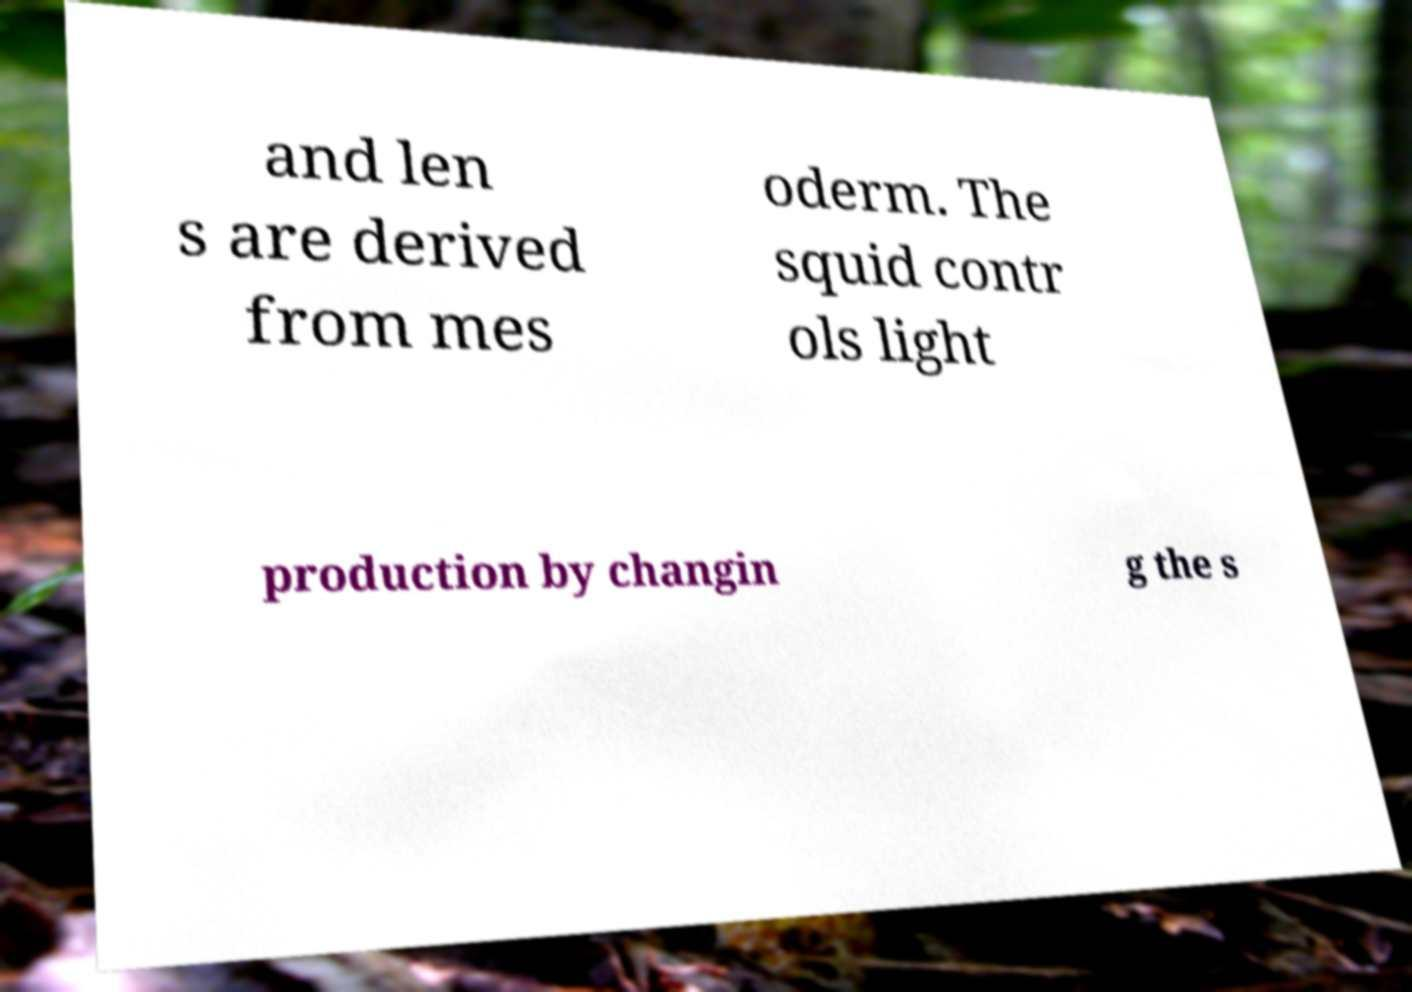There's text embedded in this image that I need extracted. Can you transcribe it verbatim? and len s are derived from mes oderm. The squid contr ols light production by changin g the s 